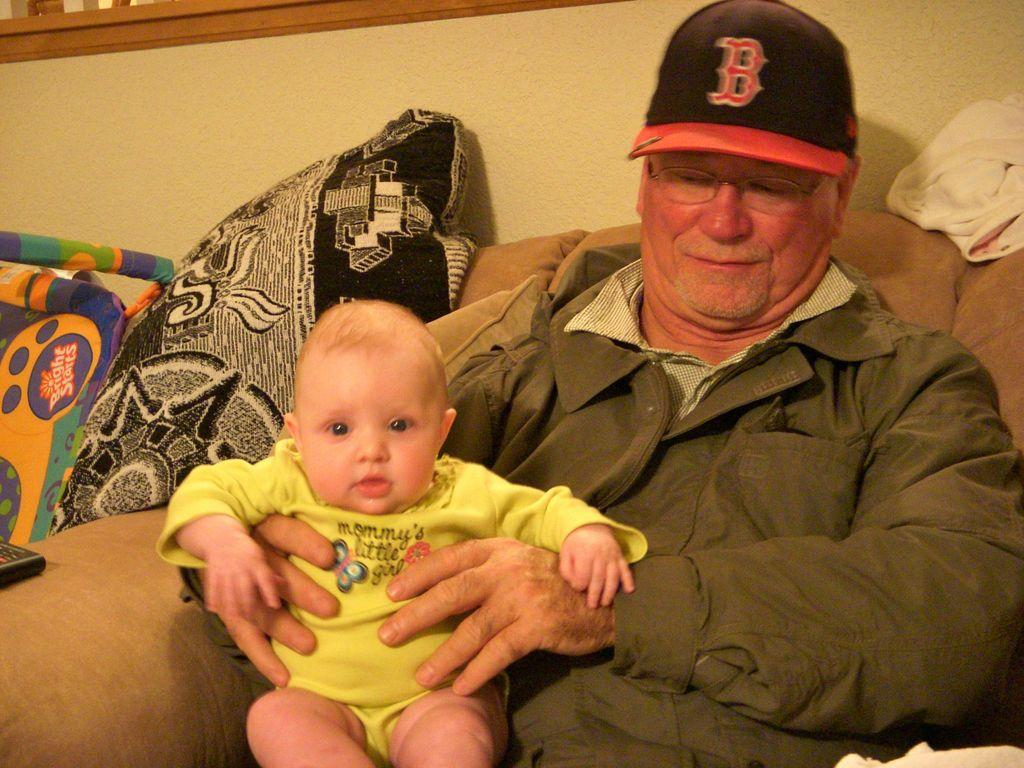What is the old man doing in the image? The old man is sitting on a sofa in the image. What is the old man wearing on his head? The old man is wearing a cap in the image. What type of clothing is the old man wearing on his upper body? The old man is wearing a jacket in the image. What is the old man holding in the image? The old man is holding a baby in the image. What can be seen in the background of the image? There is a wall in the background of the image. What is on the sofa that the old man is sitting on? There are cushions on the sofa in the image. How many bikes are parked next to the sofa in the image? There are no bikes present in the image; it only features an old man, a baby, and a sofa with cushions. 